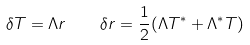Convert formula to latex. <formula><loc_0><loc_0><loc_500><loc_500>\delta T = \Lambda r \quad \delta r = { \frac { 1 } { 2 } } ( \Lambda T ^ { * } + \Lambda ^ { * } T )</formula> 